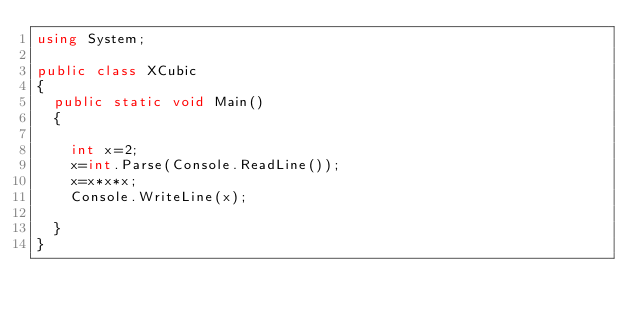<code> <loc_0><loc_0><loc_500><loc_500><_C#_>using System;

public class XCubic
{
	public static void Main()
	{
		
		int x=2;
		x=int.Parse(Console.ReadLine());
		x=x*x*x;
		Console.WriteLine(x);
		
	}
}</code> 